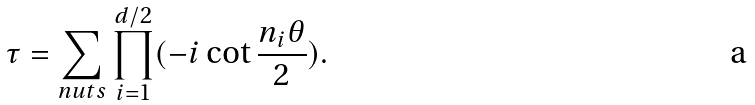Convert formula to latex. <formula><loc_0><loc_0><loc_500><loc_500>\tau = \sum _ { n u t s } \prod _ { i = 1 } ^ { d / 2 } ( - i \cot \frac { n _ { i } \theta } { 2 } ) .</formula> 